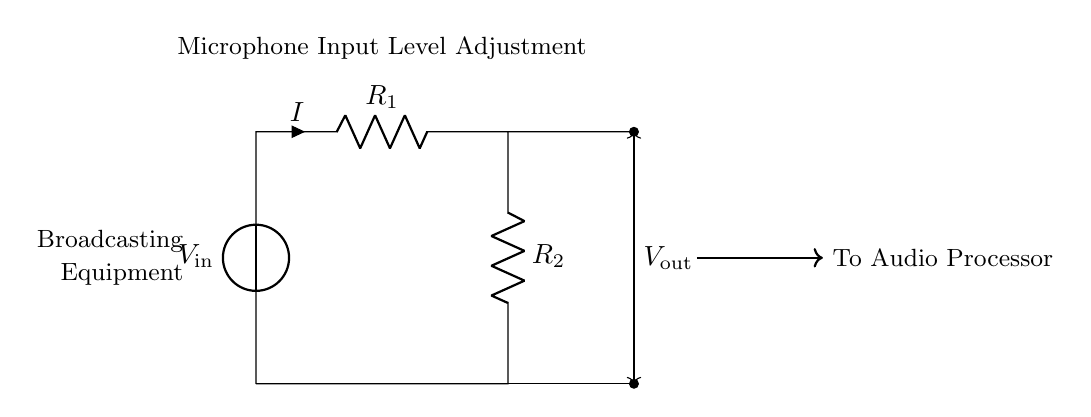What is the input voltage of the circuit? The input voltage, labeled as V in the circuit diagram, refers to the voltage applied to the circuit from the source. It is represented at the top of the circuit as V in the voltage source notation.
Answer: V in What components are used in this circuit? The components present in this voltage divider circuit include two resistors (R1 and R2) and a voltage source (V in). These are the basic elements that form the voltage divider.
Answer: Resistors and voltage source What does V out represent? V out, shown in the circuit, represents the output voltage, which is the voltage across R2 in the divider arrangement. It indicates the adjusted microphone input level generated by the voltage divider.
Answer: Output voltage How does the current flow through the circuit? The current flows from the voltage source (V in), through R1, then R2, and finally returns to the source. The flow is established in a loop from the voltage source, through both resistors, and back to the voltage source.
Answer: Clockwise What is the relationship between R1 and R2 in this circuit? R1 and R2 form the ratio that determines the distribution of voltage in the voltage divider. The output voltage is proportional to the resistance of R2 relative to the total resistance (R1 + R2), which controls the output voltage level.
Answer: Voltage ratio How would increasing R2 affect V out? Increasing R2 would increase V out because a higher resistance allows a greater portion of V in to be dropped across it, according to the voltage divider rule, making the output voltage higher.
Answer: V out increases What is the purpose of the voltage divider in broadcasting equipment? The voltage divider is used to adjust microphone input levels to ensure the audio signal is balanced and within the acceptable range for processing in broadcasting equipment, preventing distortion or amplification issues.
Answer: Level adjustment 